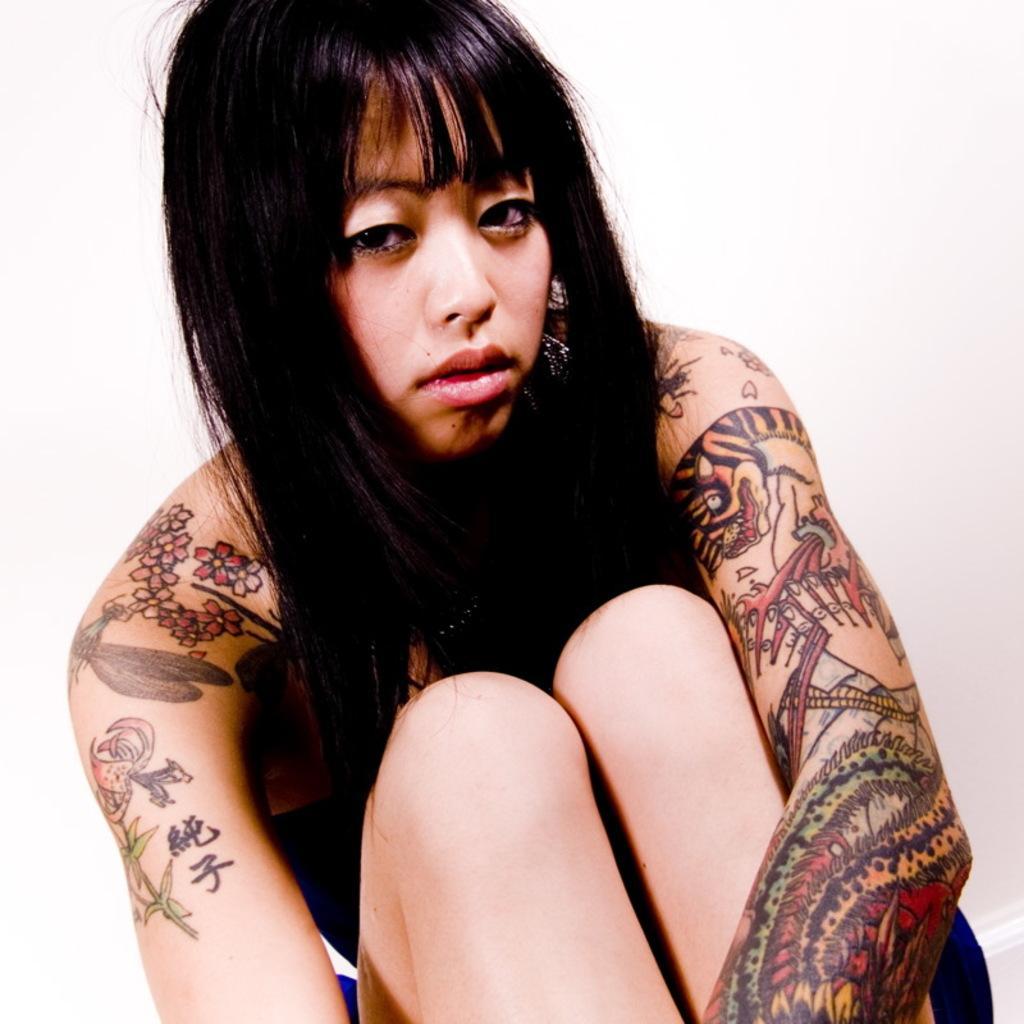What is the main subject of the image? There is a person in the image. Can you describe any distinguishing features of the person? The person has tattoos on their body. What is the color of the background in the image? The background of the image is white. What type of wax is used to create the tattoos on the person's body in the image? There is no information about the type of wax used to create the tattoos, as the focus is on the tattoos themselves and not the process of creating them. 